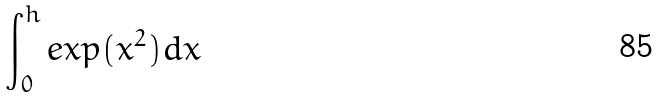Convert formula to latex. <formula><loc_0><loc_0><loc_500><loc_500>\int _ { 0 } ^ { h } e x p ( x ^ { 2 } ) d x</formula> 